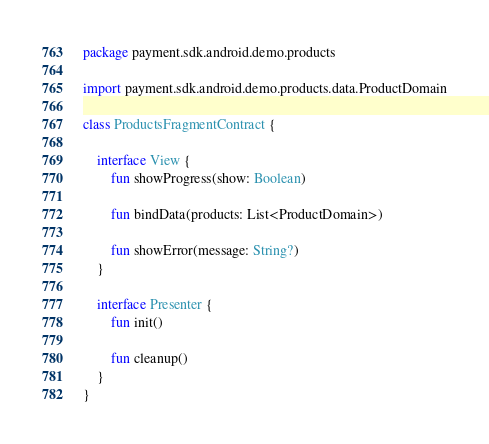<code> <loc_0><loc_0><loc_500><loc_500><_Kotlin_>package payment.sdk.android.demo.products

import payment.sdk.android.demo.products.data.ProductDomain

class ProductsFragmentContract {

    interface View {
        fun showProgress(show: Boolean)

        fun bindData(products: List<ProductDomain>)

        fun showError(message: String?)
    }

    interface Presenter {
        fun init()

        fun cleanup()
    }
}
</code> 